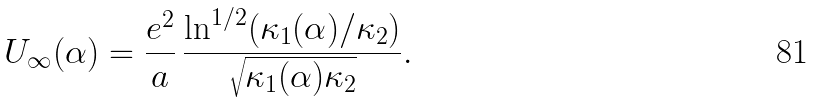Convert formula to latex. <formula><loc_0><loc_0><loc_500><loc_500>U _ { \infty } ( \alpha ) = \frac { e ^ { 2 } } { a } \, \frac { \ln ^ { 1 / 2 } ( \kappa _ { 1 } ( \alpha ) / \kappa _ { 2 } ) } { \sqrt { \kappa _ { 1 } ( \alpha ) \kappa _ { 2 } } } .</formula> 